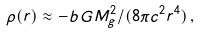<formula> <loc_0><loc_0><loc_500><loc_500>\rho ( r ) \approx - b \, G M _ { g } ^ { 2 } / ( 8 \pi c ^ { 2 } r ^ { 4 } ) \, ,</formula> 